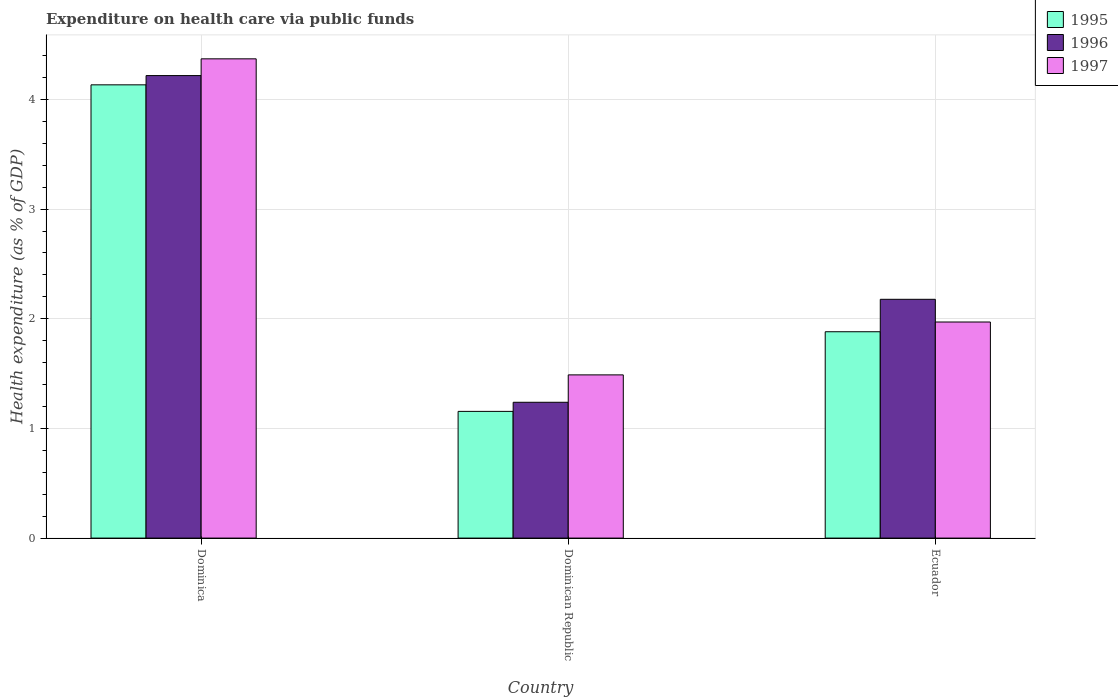How many different coloured bars are there?
Your answer should be compact. 3. What is the label of the 2nd group of bars from the left?
Keep it short and to the point. Dominican Republic. What is the expenditure made on health care in 1995 in Dominican Republic?
Offer a terse response. 1.16. Across all countries, what is the maximum expenditure made on health care in 1997?
Provide a succinct answer. 4.37. Across all countries, what is the minimum expenditure made on health care in 1996?
Your answer should be very brief. 1.24. In which country was the expenditure made on health care in 1996 maximum?
Make the answer very short. Dominica. In which country was the expenditure made on health care in 1997 minimum?
Provide a short and direct response. Dominican Republic. What is the total expenditure made on health care in 1995 in the graph?
Offer a very short reply. 7.17. What is the difference between the expenditure made on health care in 1996 in Dominican Republic and that in Ecuador?
Your answer should be very brief. -0.94. What is the difference between the expenditure made on health care in 1997 in Dominican Republic and the expenditure made on health care in 1995 in Dominica?
Keep it short and to the point. -2.64. What is the average expenditure made on health care in 1997 per country?
Your answer should be very brief. 2.61. What is the difference between the expenditure made on health care of/in 1995 and expenditure made on health care of/in 1997 in Dominica?
Make the answer very short. -0.24. In how many countries, is the expenditure made on health care in 1997 greater than 2 %?
Ensure brevity in your answer.  1. What is the ratio of the expenditure made on health care in 1997 in Dominica to that in Dominican Republic?
Provide a succinct answer. 2.94. Is the expenditure made on health care in 1995 in Dominica less than that in Dominican Republic?
Your answer should be compact. No. Is the difference between the expenditure made on health care in 1995 in Dominica and Dominican Republic greater than the difference between the expenditure made on health care in 1997 in Dominica and Dominican Republic?
Offer a very short reply. Yes. What is the difference between the highest and the second highest expenditure made on health care in 1997?
Ensure brevity in your answer.  -2.4. What is the difference between the highest and the lowest expenditure made on health care in 1997?
Keep it short and to the point. 2.88. What does the 2nd bar from the right in Dominica represents?
Your answer should be very brief. 1996. Is it the case that in every country, the sum of the expenditure made on health care in 1995 and expenditure made on health care in 1997 is greater than the expenditure made on health care in 1996?
Offer a very short reply. Yes. How many bars are there?
Make the answer very short. 9. Are all the bars in the graph horizontal?
Give a very brief answer. No. How many countries are there in the graph?
Keep it short and to the point. 3. Are the values on the major ticks of Y-axis written in scientific E-notation?
Make the answer very short. No. Does the graph contain any zero values?
Give a very brief answer. No. Does the graph contain grids?
Ensure brevity in your answer.  Yes. Where does the legend appear in the graph?
Your answer should be compact. Top right. What is the title of the graph?
Offer a terse response. Expenditure on health care via public funds. Does "1983" appear as one of the legend labels in the graph?
Ensure brevity in your answer.  No. What is the label or title of the X-axis?
Give a very brief answer. Country. What is the label or title of the Y-axis?
Keep it short and to the point. Health expenditure (as % of GDP). What is the Health expenditure (as % of GDP) in 1995 in Dominica?
Offer a very short reply. 4.13. What is the Health expenditure (as % of GDP) in 1996 in Dominica?
Your answer should be very brief. 4.22. What is the Health expenditure (as % of GDP) in 1997 in Dominica?
Your response must be concise. 4.37. What is the Health expenditure (as % of GDP) in 1995 in Dominican Republic?
Keep it short and to the point. 1.16. What is the Health expenditure (as % of GDP) in 1996 in Dominican Republic?
Give a very brief answer. 1.24. What is the Health expenditure (as % of GDP) of 1997 in Dominican Republic?
Keep it short and to the point. 1.49. What is the Health expenditure (as % of GDP) of 1995 in Ecuador?
Give a very brief answer. 1.88. What is the Health expenditure (as % of GDP) in 1996 in Ecuador?
Offer a very short reply. 2.18. What is the Health expenditure (as % of GDP) in 1997 in Ecuador?
Provide a short and direct response. 1.97. Across all countries, what is the maximum Health expenditure (as % of GDP) of 1995?
Your answer should be compact. 4.13. Across all countries, what is the maximum Health expenditure (as % of GDP) of 1996?
Keep it short and to the point. 4.22. Across all countries, what is the maximum Health expenditure (as % of GDP) in 1997?
Provide a short and direct response. 4.37. Across all countries, what is the minimum Health expenditure (as % of GDP) in 1995?
Offer a very short reply. 1.16. Across all countries, what is the minimum Health expenditure (as % of GDP) in 1996?
Provide a short and direct response. 1.24. Across all countries, what is the minimum Health expenditure (as % of GDP) of 1997?
Ensure brevity in your answer.  1.49. What is the total Health expenditure (as % of GDP) in 1995 in the graph?
Provide a succinct answer. 7.17. What is the total Health expenditure (as % of GDP) in 1996 in the graph?
Offer a terse response. 7.63. What is the total Health expenditure (as % of GDP) of 1997 in the graph?
Your response must be concise. 7.83. What is the difference between the Health expenditure (as % of GDP) of 1995 in Dominica and that in Dominican Republic?
Keep it short and to the point. 2.98. What is the difference between the Health expenditure (as % of GDP) of 1996 in Dominica and that in Dominican Republic?
Keep it short and to the point. 2.98. What is the difference between the Health expenditure (as % of GDP) of 1997 in Dominica and that in Dominican Republic?
Offer a terse response. 2.88. What is the difference between the Health expenditure (as % of GDP) of 1995 in Dominica and that in Ecuador?
Keep it short and to the point. 2.25. What is the difference between the Health expenditure (as % of GDP) of 1996 in Dominica and that in Ecuador?
Provide a succinct answer. 2.04. What is the difference between the Health expenditure (as % of GDP) in 1997 in Dominica and that in Ecuador?
Keep it short and to the point. 2.4. What is the difference between the Health expenditure (as % of GDP) in 1995 in Dominican Republic and that in Ecuador?
Keep it short and to the point. -0.73. What is the difference between the Health expenditure (as % of GDP) in 1996 in Dominican Republic and that in Ecuador?
Keep it short and to the point. -0.94. What is the difference between the Health expenditure (as % of GDP) in 1997 in Dominican Republic and that in Ecuador?
Keep it short and to the point. -0.48. What is the difference between the Health expenditure (as % of GDP) in 1995 in Dominica and the Health expenditure (as % of GDP) in 1996 in Dominican Republic?
Provide a succinct answer. 2.89. What is the difference between the Health expenditure (as % of GDP) of 1995 in Dominica and the Health expenditure (as % of GDP) of 1997 in Dominican Republic?
Make the answer very short. 2.64. What is the difference between the Health expenditure (as % of GDP) in 1996 in Dominica and the Health expenditure (as % of GDP) in 1997 in Dominican Republic?
Give a very brief answer. 2.73. What is the difference between the Health expenditure (as % of GDP) of 1995 in Dominica and the Health expenditure (as % of GDP) of 1996 in Ecuador?
Keep it short and to the point. 1.96. What is the difference between the Health expenditure (as % of GDP) in 1995 in Dominica and the Health expenditure (as % of GDP) in 1997 in Ecuador?
Make the answer very short. 2.16. What is the difference between the Health expenditure (as % of GDP) in 1996 in Dominica and the Health expenditure (as % of GDP) in 1997 in Ecuador?
Ensure brevity in your answer.  2.25. What is the difference between the Health expenditure (as % of GDP) of 1995 in Dominican Republic and the Health expenditure (as % of GDP) of 1996 in Ecuador?
Your answer should be very brief. -1.02. What is the difference between the Health expenditure (as % of GDP) of 1995 in Dominican Republic and the Health expenditure (as % of GDP) of 1997 in Ecuador?
Offer a terse response. -0.82. What is the difference between the Health expenditure (as % of GDP) of 1996 in Dominican Republic and the Health expenditure (as % of GDP) of 1997 in Ecuador?
Make the answer very short. -0.73. What is the average Health expenditure (as % of GDP) of 1995 per country?
Your response must be concise. 2.39. What is the average Health expenditure (as % of GDP) in 1996 per country?
Keep it short and to the point. 2.54. What is the average Health expenditure (as % of GDP) of 1997 per country?
Ensure brevity in your answer.  2.61. What is the difference between the Health expenditure (as % of GDP) in 1995 and Health expenditure (as % of GDP) in 1996 in Dominica?
Make the answer very short. -0.08. What is the difference between the Health expenditure (as % of GDP) of 1995 and Health expenditure (as % of GDP) of 1997 in Dominica?
Your response must be concise. -0.24. What is the difference between the Health expenditure (as % of GDP) of 1996 and Health expenditure (as % of GDP) of 1997 in Dominica?
Ensure brevity in your answer.  -0.15. What is the difference between the Health expenditure (as % of GDP) in 1995 and Health expenditure (as % of GDP) in 1996 in Dominican Republic?
Offer a very short reply. -0.08. What is the difference between the Health expenditure (as % of GDP) in 1995 and Health expenditure (as % of GDP) in 1997 in Dominican Republic?
Provide a short and direct response. -0.33. What is the difference between the Health expenditure (as % of GDP) in 1996 and Health expenditure (as % of GDP) in 1997 in Dominican Republic?
Offer a terse response. -0.25. What is the difference between the Health expenditure (as % of GDP) in 1995 and Health expenditure (as % of GDP) in 1996 in Ecuador?
Your answer should be very brief. -0.3. What is the difference between the Health expenditure (as % of GDP) of 1995 and Health expenditure (as % of GDP) of 1997 in Ecuador?
Your response must be concise. -0.09. What is the difference between the Health expenditure (as % of GDP) in 1996 and Health expenditure (as % of GDP) in 1997 in Ecuador?
Your response must be concise. 0.21. What is the ratio of the Health expenditure (as % of GDP) of 1995 in Dominica to that in Dominican Republic?
Your answer should be compact. 3.58. What is the ratio of the Health expenditure (as % of GDP) in 1996 in Dominica to that in Dominican Republic?
Provide a short and direct response. 3.41. What is the ratio of the Health expenditure (as % of GDP) of 1997 in Dominica to that in Dominican Republic?
Your answer should be very brief. 2.94. What is the ratio of the Health expenditure (as % of GDP) in 1995 in Dominica to that in Ecuador?
Offer a terse response. 2.2. What is the ratio of the Health expenditure (as % of GDP) in 1996 in Dominica to that in Ecuador?
Your response must be concise. 1.94. What is the ratio of the Health expenditure (as % of GDP) of 1997 in Dominica to that in Ecuador?
Give a very brief answer. 2.22. What is the ratio of the Health expenditure (as % of GDP) in 1995 in Dominican Republic to that in Ecuador?
Offer a terse response. 0.61. What is the ratio of the Health expenditure (as % of GDP) in 1996 in Dominican Republic to that in Ecuador?
Provide a succinct answer. 0.57. What is the ratio of the Health expenditure (as % of GDP) in 1997 in Dominican Republic to that in Ecuador?
Provide a short and direct response. 0.76. What is the difference between the highest and the second highest Health expenditure (as % of GDP) of 1995?
Give a very brief answer. 2.25. What is the difference between the highest and the second highest Health expenditure (as % of GDP) in 1996?
Provide a short and direct response. 2.04. What is the difference between the highest and the second highest Health expenditure (as % of GDP) of 1997?
Offer a very short reply. 2.4. What is the difference between the highest and the lowest Health expenditure (as % of GDP) of 1995?
Provide a short and direct response. 2.98. What is the difference between the highest and the lowest Health expenditure (as % of GDP) of 1996?
Offer a terse response. 2.98. What is the difference between the highest and the lowest Health expenditure (as % of GDP) of 1997?
Make the answer very short. 2.88. 